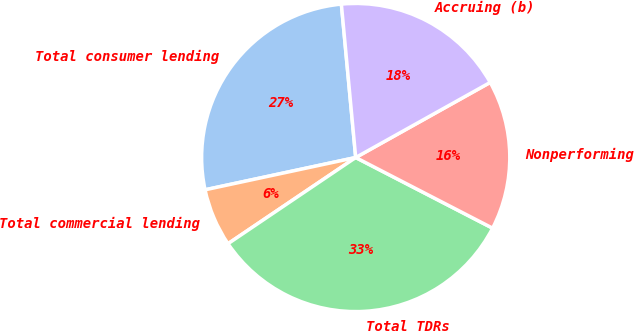<chart> <loc_0><loc_0><loc_500><loc_500><pie_chart><fcel>Total consumer lending<fcel>Total commercial lending<fcel>Total TDRs<fcel>Nonperforming<fcel>Accruing (b)<nl><fcel>26.88%<fcel>6.09%<fcel>32.97%<fcel>15.69%<fcel>18.38%<nl></chart> 